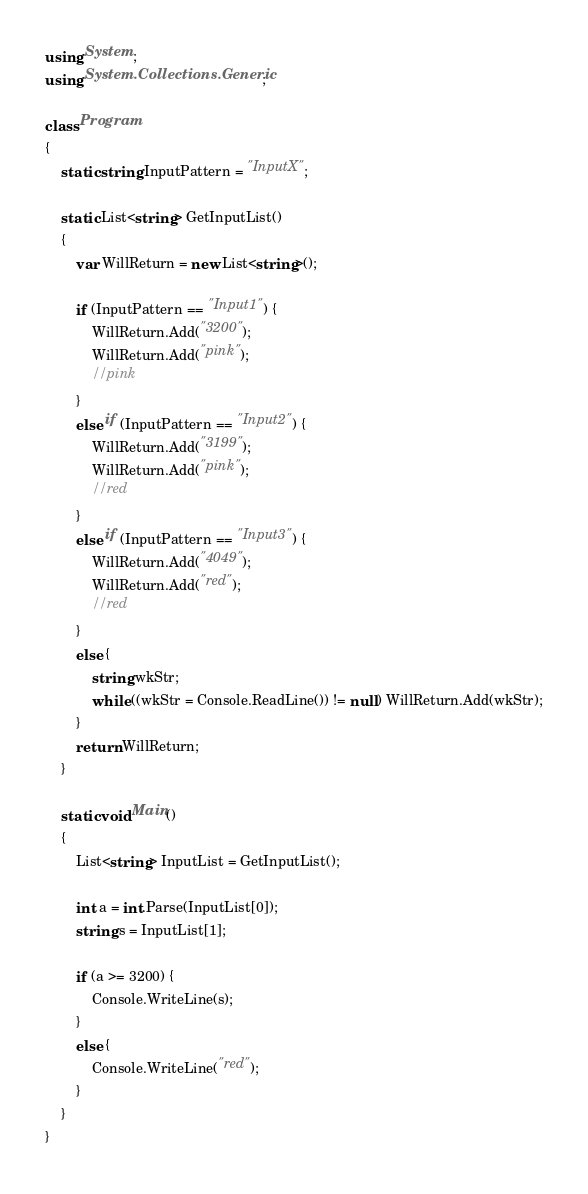Convert code to text. <code><loc_0><loc_0><loc_500><loc_500><_C#_>using System;
using System.Collections.Generic;

class Program
{
    static string InputPattern = "InputX";

    static List<string> GetInputList()
    {
        var WillReturn = new List<string>();

        if (InputPattern == "Input1") {
            WillReturn.Add("3200");
            WillReturn.Add("pink");
            //pink
        }
        else if (InputPattern == "Input2") {
            WillReturn.Add("3199");
            WillReturn.Add("pink");
            //red
        }
        else if (InputPattern == "Input3") {
            WillReturn.Add("4049");
            WillReturn.Add("red");
            //red
        }
        else {
            string wkStr;
            while ((wkStr = Console.ReadLine()) != null) WillReturn.Add(wkStr);
        }
        return WillReturn;
    }

    static void Main()
    {
        List<string> InputList = GetInputList();

        int a = int.Parse(InputList[0]);
        string s = InputList[1];

        if (a >= 3200) {
            Console.WriteLine(s);
        }
        else {
            Console.WriteLine("red");
        }
    }
}
</code> 